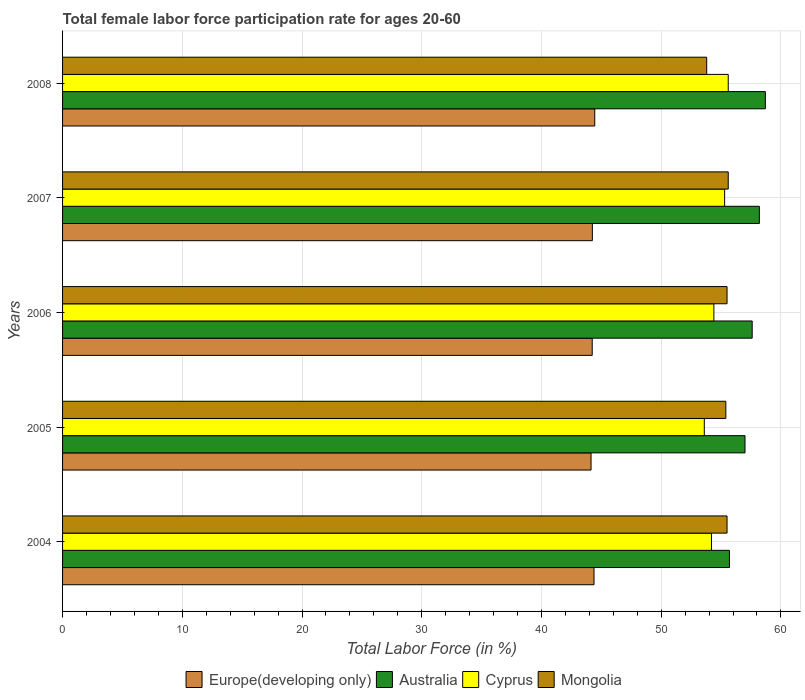How many different coloured bars are there?
Give a very brief answer. 4. Are the number of bars per tick equal to the number of legend labels?
Provide a short and direct response. Yes. How many bars are there on the 2nd tick from the top?
Offer a very short reply. 4. In how many cases, is the number of bars for a given year not equal to the number of legend labels?
Provide a short and direct response. 0. What is the female labor force participation rate in Australia in 2005?
Keep it short and to the point. 57. Across all years, what is the maximum female labor force participation rate in Mongolia?
Your answer should be compact. 55.6. Across all years, what is the minimum female labor force participation rate in Europe(developing only)?
Keep it short and to the point. 44.14. In which year was the female labor force participation rate in Australia minimum?
Offer a terse response. 2004. What is the total female labor force participation rate in Australia in the graph?
Provide a succinct answer. 287.2. What is the difference between the female labor force participation rate in Mongolia in 2005 and that in 2008?
Provide a short and direct response. 1.6. What is the difference between the female labor force participation rate in Cyprus in 2005 and the female labor force participation rate in Australia in 2007?
Provide a succinct answer. -4.6. What is the average female labor force participation rate in Australia per year?
Provide a short and direct response. 57.44. In the year 2008, what is the difference between the female labor force participation rate in Australia and female labor force participation rate in Europe(developing only)?
Offer a terse response. 14.25. In how many years, is the female labor force participation rate in Australia greater than 18 %?
Make the answer very short. 5. What is the ratio of the female labor force participation rate in Mongolia in 2005 to that in 2008?
Offer a terse response. 1.03. Is the female labor force participation rate in Australia in 2005 less than that in 2007?
Provide a short and direct response. Yes. Is the difference between the female labor force participation rate in Australia in 2004 and 2007 greater than the difference between the female labor force participation rate in Europe(developing only) in 2004 and 2007?
Provide a short and direct response. No. What is the difference between the highest and the second highest female labor force participation rate in Europe(developing only)?
Offer a terse response. 0.06. In how many years, is the female labor force participation rate in Australia greater than the average female labor force participation rate in Australia taken over all years?
Your answer should be compact. 3. What does the 4th bar from the top in 2006 represents?
Ensure brevity in your answer.  Europe(developing only). What does the 2nd bar from the bottom in 2007 represents?
Provide a succinct answer. Australia. Is it the case that in every year, the sum of the female labor force participation rate in Australia and female labor force participation rate in Cyprus is greater than the female labor force participation rate in Mongolia?
Make the answer very short. Yes. Are all the bars in the graph horizontal?
Provide a short and direct response. Yes. Are the values on the major ticks of X-axis written in scientific E-notation?
Give a very brief answer. No. Does the graph contain grids?
Keep it short and to the point. Yes. How many legend labels are there?
Give a very brief answer. 4. How are the legend labels stacked?
Offer a terse response. Horizontal. What is the title of the graph?
Offer a very short reply. Total female labor force participation rate for ages 20-60. What is the Total Labor Force (in %) of Europe(developing only) in 2004?
Offer a very short reply. 44.39. What is the Total Labor Force (in %) in Australia in 2004?
Your answer should be compact. 55.7. What is the Total Labor Force (in %) in Cyprus in 2004?
Provide a succinct answer. 54.2. What is the Total Labor Force (in %) of Mongolia in 2004?
Offer a terse response. 55.5. What is the Total Labor Force (in %) of Europe(developing only) in 2005?
Offer a terse response. 44.14. What is the Total Labor Force (in %) of Australia in 2005?
Provide a short and direct response. 57. What is the Total Labor Force (in %) in Cyprus in 2005?
Offer a very short reply. 53.6. What is the Total Labor Force (in %) of Mongolia in 2005?
Give a very brief answer. 55.4. What is the Total Labor Force (in %) of Europe(developing only) in 2006?
Offer a terse response. 44.24. What is the Total Labor Force (in %) of Australia in 2006?
Ensure brevity in your answer.  57.6. What is the Total Labor Force (in %) in Cyprus in 2006?
Your response must be concise. 54.4. What is the Total Labor Force (in %) in Mongolia in 2006?
Provide a short and direct response. 55.5. What is the Total Labor Force (in %) in Europe(developing only) in 2007?
Give a very brief answer. 44.25. What is the Total Labor Force (in %) of Australia in 2007?
Provide a succinct answer. 58.2. What is the Total Labor Force (in %) of Cyprus in 2007?
Ensure brevity in your answer.  55.3. What is the Total Labor Force (in %) of Mongolia in 2007?
Offer a very short reply. 55.6. What is the Total Labor Force (in %) in Europe(developing only) in 2008?
Ensure brevity in your answer.  44.45. What is the Total Labor Force (in %) of Australia in 2008?
Make the answer very short. 58.7. What is the Total Labor Force (in %) of Cyprus in 2008?
Provide a succinct answer. 55.6. What is the Total Labor Force (in %) in Mongolia in 2008?
Offer a terse response. 53.8. Across all years, what is the maximum Total Labor Force (in %) of Europe(developing only)?
Provide a succinct answer. 44.45. Across all years, what is the maximum Total Labor Force (in %) of Australia?
Your answer should be very brief. 58.7. Across all years, what is the maximum Total Labor Force (in %) in Cyprus?
Offer a very short reply. 55.6. Across all years, what is the maximum Total Labor Force (in %) in Mongolia?
Keep it short and to the point. 55.6. Across all years, what is the minimum Total Labor Force (in %) of Europe(developing only)?
Provide a succinct answer. 44.14. Across all years, what is the minimum Total Labor Force (in %) in Australia?
Ensure brevity in your answer.  55.7. Across all years, what is the minimum Total Labor Force (in %) of Cyprus?
Offer a terse response. 53.6. Across all years, what is the minimum Total Labor Force (in %) of Mongolia?
Provide a succinct answer. 53.8. What is the total Total Labor Force (in %) of Europe(developing only) in the graph?
Provide a succinct answer. 221.47. What is the total Total Labor Force (in %) of Australia in the graph?
Your answer should be very brief. 287.2. What is the total Total Labor Force (in %) in Cyprus in the graph?
Offer a terse response. 273.1. What is the total Total Labor Force (in %) of Mongolia in the graph?
Offer a very short reply. 275.8. What is the difference between the Total Labor Force (in %) in Europe(developing only) in 2004 and that in 2005?
Make the answer very short. 0.25. What is the difference between the Total Labor Force (in %) of Australia in 2004 and that in 2005?
Make the answer very short. -1.3. What is the difference between the Total Labor Force (in %) in Cyprus in 2004 and that in 2005?
Offer a terse response. 0.6. What is the difference between the Total Labor Force (in %) of Mongolia in 2004 and that in 2005?
Give a very brief answer. 0.1. What is the difference between the Total Labor Force (in %) of Europe(developing only) in 2004 and that in 2006?
Make the answer very short. 0.15. What is the difference between the Total Labor Force (in %) of Australia in 2004 and that in 2006?
Your response must be concise. -1.9. What is the difference between the Total Labor Force (in %) in Cyprus in 2004 and that in 2006?
Ensure brevity in your answer.  -0.2. What is the difference between the Total Labor Force (in %) in Europe(developing only) in 2004 and that in 2007?
Provide a short and direct response. 0.14. What is the difference between the Total Labor Force (in %) in Mongolia in 2004 and that in 2007?
Provide a succinct answer. -0.1. What is the difference between the Total Labor Force (in %) of Europe(developing only) in 2004 and that in 2008?
Provide a succinct answer. -0.06. What is the difference between the Total Labor Force (in %) of Australia in 2004 and that in 2008?
Provide a succinct answer. -3. What is the difference between the Total Labor Force (in %) in Mongolia in 2004 and that in 2008?
Offer a terse response. 1.7. What is the difference between the Total Labor Force (in %) in Europe(developing only) in 2005 and that in 2006?
Provide a succinct answer. -0.1. What is the difference between the Total Labor Force (in %) of Australia in 2005 and that in 2006?
Provide a short and direct response. -0.6. What is the difference between the Total Labor Force (in %) of Cyprus in 2005 and that in 2006?
Offer a very short reply. -0.8. What is the difference between the Total Labor Force (in %) in Europe(developing only) in 2005 and that in 2007?
Make the answer very short. -0.11. What is the difference between the Total Labor Force (in %) in Europe(developing only) in 2005 and that in 2008?
Offer a very short reply. -0.31. What is the difference between the Total Labor Force (in %) of Europe(developing only) in 2006 and that in 2007?
Your response must be concise. -0.01. What is the difference between the Total Labor Force (in %) of Mongolia in 2006 and that in 2007?
Keep it short and to the point. -0.1. What is the difference between the Total Labor Force (in %) of Europe(developing only) in 2006 and that in 2008?
Your answer should be very brief. -0.21. What is the difference between the Total Labor Force (in %) of Cyprus in 2006 and that in 2008?
Keep it short and to the point. -1.2. What is the difference between the Total Labor Force (in %) in Europe(developing only) in 2007 and that in 2008?
Ensure brevity in your answer.  -0.2. What is the difference between the Total Labor Force (in %) of Cyprus in 2007 and that in 2008?
Offer a terse response. -0.3. What is the difference between the Total Labor Force (in %) in Mongolia in 2007 and that in 2008?
Your answer should be very brief. 1.8. What is the difference between the Total Labor Force (in %) of Europe(developing only) in 2004 and the Total Labor Force (in %) of Australia in 2005?
Your answer should be compact. -12.61. What is the difference between the Total Labor Force (in %) in Europe(developing only) in 2004 and the Total Labor Force (in %) in Cyprus in 2005?
Offer a very short reply. -9.21. What is the difference between the Total Labor Force (in %) in Europe(developing only) in 2004 and the Total Labor Force (in %) in Mongolia in 2005?
Offer a very short reply. -11.01. What is the difference between the Total Labor Force (in %) of Australia in 2004 and the Total Labor Force (in %) of Mongolia in 2005?
Keep it short and to the point. 0.3. What is the difference between the Total Labor Force (in %) of Cyprus in 2004 and the Total Labor Force (in %) of Mongolia in 2005?
Offer a terse response. -1.2. What is the difference between the Total Labor Force (in %) of Europe(developing only) in 2004 and the Total Labor Force (in %) of Australia in 2006?
Give a very brief answer. -13.21. What is the difference between the Total Labor Force (in %) in Europe(developing only) in 2004 and the Total Labor Force (in %) in Cyprus in 2006?
Offer a very short reply. -10.01. What is the difference between the Total Labor Force (in %) in Europe(developing only) in 2004 and the Total Labor Force (in %) in Mongolia in 2006?
Offer a terse response. -11.11. What is the difference between the Total Labor Force (in %) of Australia in 2004 and the Total Labor Force (in %) of Cyprus in 2006?
Keep it short and to the point. 1.3. What is the difference between the Total Labor Force (in %) in Australia in 2004 and the Total Labor Force (in %) in Mongolia in 2006?
Offer a very short reply. 0.2. What is the difference between the Total Labor Force (in %) of Cyprus in 2004 and the Total Labor Force (in %) of Mongolia in 2006?
Keep it short and to the point. -1.3. What is the difference between the Total Labor Force (in %) in Europe(developing only) in 2004 and the Total Labor Force (in %) in Australia in 2007?
Ensure brevity in your answer.  -13.81. What is the difference between the Total Labor Force (in %) in Europe(developing only) in 2004 and the Total Labor Force (in %) in Cyprus in 2007?
Offer a very short reply. -10.91. What is the difference between the Total Labor Force (in %) in Europe(developing only) in 2004 and the Total Labor Force (in %) in Mongolia in 2007?
Provide a succinct answer. -11.21. What is the difference between the Total Labor Force (in %) in Australia in 2004 and the Total Labor Force (in %) in Cyprus in 2007?
Give a very brief answer. 0.4. What is the difference between the Total Labor Force (in %) of Australia in 2004 and the Total Labor Force (in %) of Mongolia in 2007?
Your answer should be very brief. 0.1. What is the difference between the Total Labor Force (in %) in Cyprus in 2004 and the Total Labor Force (in %) in Mongolia in 2007?
Provide a short and direct response. -1.4. What is the difference between the Total Labor Force (in %) of Europe(developing only) in 2004 and the Total Labor Force (in %) of Australia in 2008?
Your response must be concise. -14.31. What is the difference between the Total Labor Force (in %) in Europe(developing only) in 2004 and the Total Labor Force (in %) in Cyprus in 2008?
Make the answer very short. -11.21. What is the difference between the Total Labor Force (in %) of Europe(developing only) in 2004 and the Total Labor Force (in %) of Mongolia in 2008?
Provide a succinct answer. -9.41. What is the difference between the Total Labor Force (in %) in Europe(developing only) in 2005 and the Total Labor Force (in %) in Australia in 2006?
Make the answer very short. -13.46. What is the difference between the Total Labor Force (in %) in Europe(developing only) in 2005 and the Total Labor Force (in %) in Cyprus in 2006?
Offer a very short reply. -10.26. What is the difference between the Total Labor Force (in %) in Europe(developing only) in 2005 and the Total Labor Force (in %) in Mongolia in 2006?
Your answer should be compact. -11.36. What is the difference between the Total Labor Force (in %) of Australia in 2005 and the Total Labor Force (in %) of Cyprus in 2006?
Your response must be concise. 2.6. What is the difference between the Total Labor Force (in %) of Europe(developing only) in 2005 and the Total Labor Force (in %) of Australia in 2007?
Your answer should be very brief. -14.06. What is the difference between the Total Labor Force (in %) of Europe(developing only) in 2005 and the Total Labor Force (in %) of Cyprus in 2007?
Offer a very short reply. -11.16. What is the difference between the Total Labor Force (in %) of Europe(developing only) in 2005 and the Total Labor Force (in %) of Mongolia in 2007?
Make the answer very short. -11.46. What is the difference between the Total Labor Force (in %) in Australia in 2005 and the Total Labor Force (in %) in Mongolia in 2007?
Give a very brief answer. 1.4. What is the difference between the Total Labor Force (in %) in Europe(developing only) in 2005 and the Total Labor Force (in %) in Australia in 2008?
Make the answer very short. -14.56. What is the difference between the Total Labor Force (in %) in Europe(developing only) in 2005 and the Total Labor Force (in %) in Cyprus in 2008?
Your answer should be compact. -11.46. What is the difference between the Total Labor Force (in %) of Europe(developing only) in 2005 and the Total Labor Force (in %) of Mongolia in 2008?
Provide a succinct answer. -9.66. What is the difference between the Total Labor Force (in %) of Australia in 2005 and the Total Labor Force (in %) of Cyprus in 2008?
Your answer should be compact. 1.4. What is the difference between the Total Labor Force (in %) in Cyprus in 2005 and the Total Labor Force (in %) in Mongolia in 2008?
Provide a succinct answer. -0.2. What is the difference between the Total Labor Force (in %) of Europe(developing only) in 2006 and the Total Labor Force (in %) of Australia in 2007?
Provide a succinct answer. -13.96. What is the difference between the Total Labor Force (in %) of Europe(developing only) in 2006 and the Total Labor Force (in %) of Cyprus in 2007?
Provide a short and direct response. -11.06. What is the difference between the Total Labor Force (in %) in Europe(developing only) in 2006 and the Total Labor Force (in %) in Mongolia in 2007?
Offer a terse response. -11.36. What is the difference between the Total Labor Force (in %) in Australia in 2006 and the Total Labor Force (in %) in Cyprus in 2007?
Offer a terse response. 2.3. What is the difference between the Total Labor Force (in %) in Australia in 2006 and the Total Labor Force (in %) in Mongolia in 2007?
Ensure brevity in your answer.  2. What is the difference between the Total Labor Force (in %) of Cyprus in 2006 and the Total Labor Force (in %) of Mongolia in 2007?
Your answer should be very brief. -1.2. What is the difference between the Total Labor Force (in %) in Europe(developing only) in 2006 and the Total Labor Force (in %) in Australia in 2008?
Ensure brevity in your answer.  -14.46. What is the difference between the Total Labor Force (in %) of Europe(developing only) in 2006 and the Total Labor Force (in %) of Cyprus in 2008?
Your answer should be compact. -11.36. What is the difference between the Total Labor Force (in %) of Europe(developing only) in 2006 and the Total Labor Force (in %) of Mongolia in 2008?
Give a very brief answer. -9.56. What is the difference between the Total Labor Force (in %) of Australia in 2006 and the Total Labor Force (in %) of Mongolia in 2008?
Your response must be concise. 3.8. What is the difference between the Total Labor Force (in %) in Cyprus in 2006 and the Total Labor Force (in %) in Mongolia in 2008?
Give a very brief answer. 0.6. What is the difference between the Total Labor Force (in %) in Europe(developing only) in 2007 and the Total Labor Force (in %) in Australia in 2008?
Your response must be concise. -14.45. What is the difference between the Total Labor Force (in %) in Europe(developing only) in 2007 and the Total Labor Force (in %) in Cyprus in 2008?
Ensure brevity in your answer.  -11.35. What is the difference between the Total Labor Force (in %) in Europe(developing only) in 2007 and the Total Labor Force (in %) in Mongolia in 2008?
Your answer should be compact. -9.55. What is the average Total Labor Force (in %) in Europe(developing only) per year?
Keep it short and to the point. 44.29. What is the average Total Labor Force (in %) in Australia per year?
Ensure brevity in your answer.  57.44. What is the average Total Labor Force (in %) of Cyprus per year?
Your response must be concise. 54.62. What is the average Total Labor Force (in %) of Mongolia per year?
Provide a short and direct response. 55.16. In the year 2004, what is the difference between the Total Labor Force (in %) of Europe(developing only) and Total Labor Force (in %) of Australia?
Your answer should be very brief. -11.31. In the year 2004, what is the difference between the Total Labor Force (in %) of Europe(developing only) and Total Labor Force (in %) of Cyprus?
Provide a succinct answer. -9.81. In the year 2004, what is the difference between the Total Labor Force (in %) of Europe(developing only) and Total Labor Force (in %) of Mongolia?
Provide a succinct answer. -11.11. In the year 2004, what is the difference between the Total Labor Force (in %) of Australia and Total Labor Force (in %) of Mongolia?
Your answer should be compact. 0.2. In the year 2005, what is the difference between the Total Labor Force (in %) in Europe(developing only) and Total Labor Force (in %) in Australia?
Your response must be concise. -12.86. In the year 2005, what is the difference between the Total Labor Force (in %) in Europe(developing only) and Total Labor Force (in %) in Cyprus?
Your answer should be very brief. -9.46. In the year 2005, what is the difference between the Total Labor Force (in %) in Europe(developing only) and Total Labor Force (in %) in Mongolia?
Offer a terse response. -11.26. In the year 2006, what is the difference between the Total Labor Force (in %) of Europe(developing only) and Total Labor Force (in %) of Australia?
Offer a very short reply. -13.36. In the year 2006, what is the difference between the Total Labor Force (in %) of Europe(developing only) and Total Labor Force (in %) of Cyprus?
Your response must be concise. -10.16. In the year 2006, what is the difference between the Total Labor Force (in %) of Europe(developing only) and Total Labor Force (in %) of Mongolia?
Provide a short and direct response. -11.26. In the year 2006, what is the difference between the Total Labor Force (in %) in Cyprus and Total Labor Force (in %) in Mongolia?
Your answer should be very brief. -1.1. In the year 2007, what is the difference between the Total Labor Force (in %) of Europe(developing only) and Total Labor Force (in %) of Australia?
Offer a terse response. -13.95. In the year 2007, what is the difference between the Total Labor Force (in %) of Europe(developing only) and Total Labor Force (in %) of Cyprus?
Ensure brevity in your answer.  -11.05. In the year 2007, what is the difference between the Total Labor Force (in %) in Europe(developing only) and Total Labor Force (in %) in Mongolia?
Keep it short and to the point. -11.35. In the year 2007, what is the difference between the Total Labor Force (in %) of Australia and Total Labor Force (in %) of Cyprus?
Your answer should be very brief. 2.9. In the year 2008, what is the difference between the Total Labor Force (in %) of Europe(developing only) and Total Labor Force (in %) of Australia?
Offer a very short reply. -14.25. In the year 2008, what is the difference between the Total Labor Force (in %) of Europe(developing only) and Total Labor Force (in %) of Cyprus?
Make the answer very short. -11.15. In the year 2008, what is the difference between the Total Labor Force (in %) of Europe(developing only) and Total Labor Force (in %) of Mongolia?
Keep it short and to the point. -9.35. In the year 2008, what is the difference between the Total Labor Force (in %) of Australia and Total Labor Force (in %) of Mongolia?
Your answer should be very brief. 4.9. What is the ratio of the Total Labor Force (in %) of Europe(developing only) in 2004 to that in 2005?
Your response must be concise. 1.01. What is the ratio of the Total Labor Force (in %) in Australia in 2004 to that in 2005?
Provide a succinct answer. 0.98. What is the ratio of the Total Labor Force (in %) of Cyprus in 2004 to that in 2005?
Your answer should be very brief. 1.01. What is the ratio of the Total Labor Force (in %) in Mongolia in 2004 to that in 2005?
Ensure brevity in your answer.  1. What is the ratio of the Total Labor Force (in %) of Australia in 2004 to that in 2006?
Offer a terse response. 0.97. What is the ratio of the Total Labor Force (in %) of Cyprus in 2004 to that in 2006?
Provide a short and direct response. 1. What is the ratio of the Total Labor Force (in %) in Mongolia in 2004 to that in 2006?
Your answer should be compact. 1. What is the ratio of the Total Labor Force (in %) of Cyprus in 2004 to that in 2007?
Ensure brevity in your answer.  0.98. What is the ratio of the Total Labor Force (in %) in Europe(developing only) in 2004 to that in 2008?
Provide a short and direct response. 1. What is the ratio of the Total Labor Force (in %) of Australia in 2004 to that in 2008?
Give a very brief answer. 0.95. What is the ratio of the Total Labor Force (in %) of Cyprus in 2004 to that in 2008?
Your response must be concise. 0.97. What is the ratio of the Total Labor Force (in %) in Mongolia in 2004 to that in 2008?
Your answer should be very brief. 1.03. What is the ratio of the Total Labor Force (in %) of Europe(developing only) in 2005 to that in 2006?
Your response must be concise. 1. What is the ratio of the Total Labor Force (in %) in Mongolia in 2005 to that in 2006?
Your answer should be compact. 1. What is the ratio of the Total Labor Force (in %) of Australia in 2005 to that in 2007?
Keep it short and to the point. 0.98. What is the ratio of the Total Labor Force (in %) in Cyprus in 2005 to that in 2007?
Your answer should be compact. 0.97. What is the ratio of the Total Labor Force (in %) of Mongolia in 2005 to that in 2007?
Provide a succinct answer. 1. What is the ratio of the Total Labor Force (in %) in Europe(developing only) in 2005 to that in 2008?
Provide a succinct answer. 0.99. What is the ratio of the Total Labor Force (in %) in Australia in 2005 to that in 2008?
Offer a very short reply. 0.97. What is the ratio of the Total Labor Force (in %) of Mongolia in 2005 to that in 2008?
Give a very brief answer. 1.03. What is the ratio of the Total Labor Force (in %) of Europe(developing only) in 2006 to that in 2007?
Offer a terse response. 1. What is the ratio of the Total Labor Force (in %) of Australia in 2006 to that in 2007?
Make the answer very short. 0.99. What is the ratio of the Total Labor Force (in %) in Cyprus in 2006 to that in 2007?
Keep it short and to the point. 0.98. What is the ratio of the Total Labor Force (in %) in Australia in 2006 to that in 2008?
Ensure brevity in your answer.  0.98. What is the ratio of the Total Labor Force (in %) of Cyprus in 2006 to that in 2008?
Provide a succinct answer. 0.98. What is the ratio of the Total Labor Force (in %) of Mongolia in 2006 to that in 2008?
Ensure brevity in your answer.  1.03. What is the ratio of the Total Labor Force (in %) of Europe(developing only) in 2007 to that in 2008?
Give a very brief answer. 1. What is the ratio of the Total Labor Force (in %) in Cyprus in 2007 to that in 2008?
Offer a very short reply. 0.99. What is the ratio of the Total Labor Force (in %) of Mongolia in 2007 to that in 2008?
Ensure brevity in your answer.  1.03. What is the difference between the highest and the second highest Total Labor Force (in %) in Europe(developing only)?
Offer a terse response. 0.06. What is the difference between the highest and the second highest Total Labor Force (in %) of Australia?
Provide a succinct answer. 0.5. What is the difference between the highest and the lowest Total Labor Force (in %) in Europe(developing only)?
Ensure brevity in your answer.  0.31. What is the difference between the highest and the lowest Total Labor Force (in %) in Australia?
Keep it short and to the point. 3. 